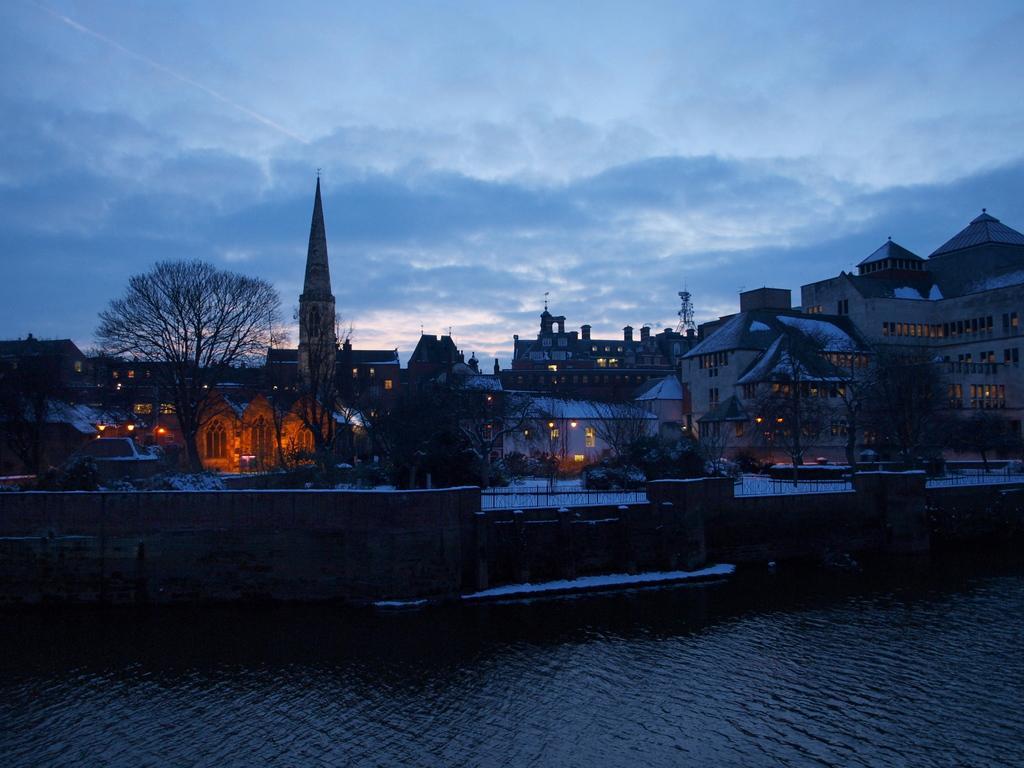Please provide a concise description of this image. This picture is clicked outside. In the foreground we can see a water body. In the center we can see the trees, houses, lights, spire and many other objects. In the background we can see the sky. 